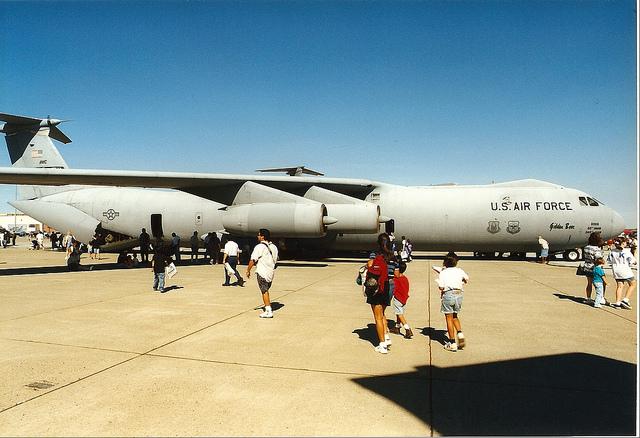Is the airplane's door open or closed?
Give a very brief answer. Open. What is the oldest military plane that is still in use?
Be succinct. Air force 1. Is this an airstrip?
Keep it brief. Yes. Is the sun in front of or behind the camera?
Be succinct. Behind. Are there people in the picture?
Short answer required. Yes. 